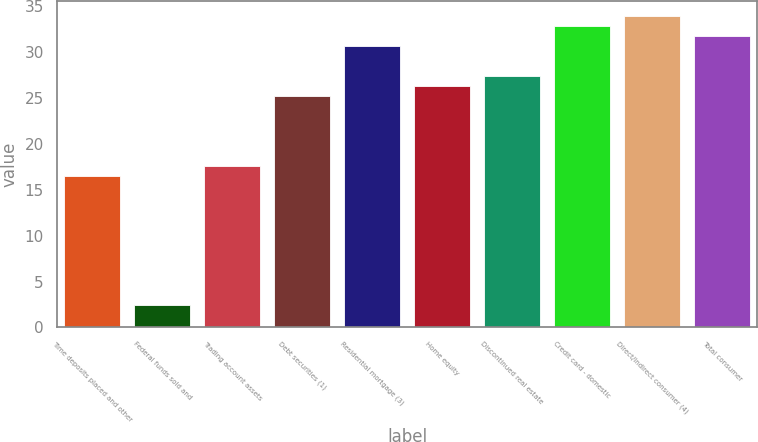Convert chart. <chart><loc_0><loc_0><loc_500><loc_500><bar_chart><fcel>Time deposits placed and other<fcel>Federal funds sold and<fcel>Trading account assets<fcel>Debt securities (1)<fcel>Residential mortgage (3)<fcel>Home equity<fcel>Discontinued real estate<fcel>Credit card - domestic<fcel>Direct/Indirect consumer (4)<fcel>Total consumer<nl><fcel>16.5<fcel>2.4<fcel>17.59<fcel>25.21<fcel>30.66<fcel>26.3<fcel>27.39<fcel>32.84<fcel>33.93<fcel>31.75<nl></chart> 